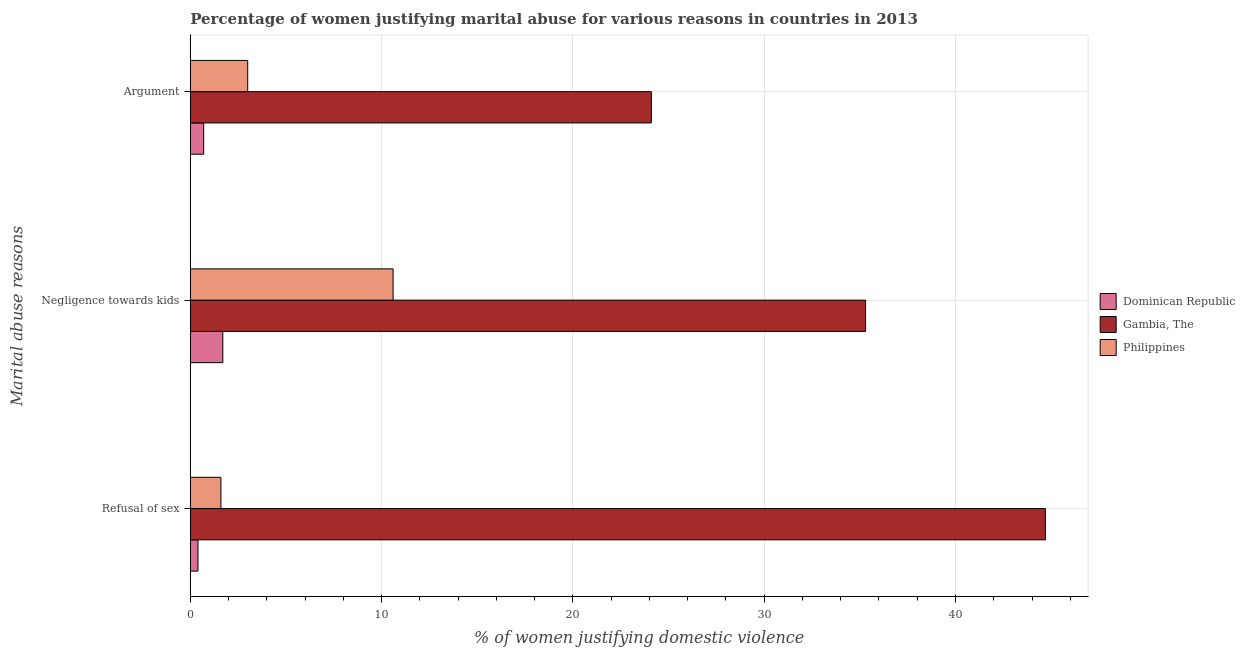How many different coloured bars are there?
Your answer should be compact. 3. How many groups of bars are there?
Provide a short and direct response. 3. Are the number of bars on each tick of the Y-axis equal?
Offer a very short reply. Yes. How many bars are there on the 2nd tick from the bottom?
Give a very brief answer. 3. What is the label of the 1st group of bars from the top?
Give a very brief answer. Argument. What is the percentage of women justifying domestic violence due to negligence towards kids in Dominican Republic?
Offer a terse response. 1.7. Across all countries, what is the maximum percentage of women justifying domestic violence due to refusal of sex?
Offer a terse response. 44.7. Across all countries, what is the minimum percentage of women justifying domestic violence due to negligence towards kids?
Your response must be concise. 1.7. In which country was the percentage of women justifying domestic violence due to refusal of sex maximum?
Make the answer very short. Gambia, The. In which country was the percentage of women justifying domestic violence due to arguments minimum?
Give a very brief answer. Dominican Republic. What is the total percentage of women justifying domestic violence due to arguments in the graph?
Your answer should be compact. 27.8. What is the difference between the percentage of women justifying domestic violence due to negligence towards kids in Philippines and that in Gambia, The?
Your answer should be very brief. -24.7. What is the average percentage of women justifying domestic violence due to arguments per country?
Make the answer very short. 9.27. What is the difference between the percentage of women justifying domestic violence due to arguments and percentage of women justifying domestic violence due to negligence towards kids in Dominican Republic?
Your answer should be compact. -1. In how many countries, is the percentage of women justifying domestic violence due to refusal of sex greater than 14 %?
Your answer should be compact. 1. What is the ratio of the percentage of women justifying domestic violence due to negligence towards kids in Gambia, The to that in Dominican Republic?
Ensure brevity in your answer.  20.76. Is the difference between the percentage of women justifying domestic violence due to arguments in Dominican Republic and Philippines greater than the difference between the percentage of women justifying domestic violence due to refusal of sex in Dominican Republic and Philippines?
Your response must be concise. No. What is the difference between the highest and the second highest percentage of women justifying domestic violence due to refusal of sex?
Make the answer very short. 43.1. What is the difference between the highest and the lowest percentage of women justifying domestic violence due to negligence towards kids?
Make the answer very short. 33.6. In how many countries, is the percentage of women justifying domestic violence due to refusal of sex greater than the average percentage of women justifying domestic violence due to refusal of sex taken over all countries?
Your answer should be compact. 1. Is the sum of the percentage of women justifying domestic violence due to refusal of sex in Philippines and Dominican Republic greater than the maximum percentage of women justifying domestic violence due to negligence towards kids across all countries?
Your response must be concise. No. What does the 3rd bar from the top in Negligence towards kids represents?
Offer a terse response. Dominican Republic. How many bars are there?
Provide a succinct answer. 9. Are all the bars in the graph horizontal?
Your response must be concise. Yes. What is the difference between two consecutive major ticks on the X-axis?
Offer a very short reply. 10. Are the values on the major ticks of X-axis written in scientific E-notation?
Offer a very short reply. No. Does the graph contain grids?
Your response must be concise. Yes. What is the title of the graph?
Ensure brevity in your answer.  Percentage of women justifying marital abuse for various reasons in countries in 2013. Does "Jamaica" appear as one of the legend labels in the graph?
Offer a terse response. No. What is the label or title of the X-axis?
Your response must be concise. % of women justifying domestic violence. What is the label or title of the Y-axis?
Offer a terse response. Marital abuse reasons. What is the % of women justifying domestic violence of Gambia, The in Refusal of sex?
Offer a very short reply. 44.7. What is the % of women justifying domestic violence of Dominican Republic in Negligence towards kids?
Offer a terse response. 1.7. What is the % of women justifying domestic violence in Gambia, The in Negligence towards kids?
Make the answer very short. 35.3. What is the % of women justifying domestic violence of Philippines in Negligence towards kids?
Ensure brevity in your answer.  10.6. What is the % of women justifying domestic violence of Dominican Republic in Argument?
Provide a succinct answer. 0.7. What is the % of women justifying domestic violence of Gambia, The in Argument?
Give a very brief answer. 24.1. What is the % of women justifying domestic violence in Philippines in Argument?
Your answer should be very brief. 3. Across all Marital abuse reasons, what is the maximum % of women justifying domestic violence of Dominican Republic?
Your answer should be very brief. 1.7. Across all Marital abuse reasons, what is the maximum % of women justifying domestic violence of Gambia, The?
Give a very brief answer. 44.7. Across all Marital abuse reasons, what is the minimum % of women justifying domestic violence in Gambia, The?
Offer a terse response. 24.1. What is the total % of women justifying domestic violence in Dominican Republic in the graph?
Give a very brief answer. 2.8. What is the total % of women justifying domestic violence in Gambia, The in the graph?
Your answer should be compact. 104.1. What is the difference between the % of women justifying domestic violence of Dominican Republic in Refusal of sex and that in Negligence towards kids?
Your answer should be very brief. -1.3. What is the difference between the % of women justifying domestic violence in Gambia, The in Refusal of sex and that in Negligence towards kids?
Your answer should be very brief. 9.4. What is the difference between the % of women justifying domestic violence in Philippines in Refusal of sex and that in Negligence towards kids?
Provide a short and direct response. -9. What is the difference between the % of women justifying domestic violence of Dominican Republic in Refusal of sex and that in Argument?
Offer a very short reply. -0.3. What is the difference between the % of women justifying domestic violence in Gambia, The in Refusal of sex and that in Argument?
Your response must be concise. 20.6. What is the difference between the % of women justifying domestic violence of Philippines in Refusal of sex and that in Argument?
Offer a terse response. -1.4. What is the difference between the % of women justifying domestic violence in Gambia, The in Negligence towards kids and that in Argument?
Give a very brief answer. 11.2. What is the difference between the % of women justifying domestic violence of Dominican Republic in Refusal of sex and the % of women justifying domestic violence of Gambia, The in Negligence towards kids?
Your answer should be very brief. -34.9. What is the difference between the % of women justifying domestic violence of Gambia, The in Refusal of sex and the % of women justifying domestic violence of Philippines in Negligence towards kids?
Ensure brevity in your answer.  34.1. What is the difference between the % of women justifying domestic violence in Dominican Republic in Refusal of sex and the % of women justifying domestic violence in Gambia, The in Argument?
Your answer should be compact. -23.7. What is the difference between the % of women justifying domestic violence of Gambia, The in Refusal of sex and the % of women justifying domestic violence of Philippines in Argument?
Your response must be concise. 41.7. What is the difference between the % of women justifying domestic violence in Dominican Republic in Negligence towards kids and the % of women justifying domestic violence in Gambia, The in Argument?
Make the answer very short. -22.4. What is the difference between the % of women justifying domestic violence in Gambia, The in Negligence towards kids and the % of women justifying domestic violence in Philippines in Argument?
Provide a short and direct response. 32.3. What is the average % of women justifying domestic violence in Dominican Republic per Marital abuse reasons?
Make the answer very short. 0.93. What is the average % of women justifying domestic violence of Gambia, The per Marital abuse reasons?
Offer a terse response. 34.7. What is the average % of women justifying domestic violence of Philippines per Marital abuse reasons?
Provide a succinct answer. 5.07. What is the difference between the % of women justifying domestic violence of Dominican Republic and % of women justifying domestic violence of Gambia, The in Refusal of sex?
Provide a short and direct response. -44.3. What is the difference between the % of women justifying domestic violence of Gambia, The and % of women justifying domestic violence of Philippines in Refusal of sex?
Offer a terse response. 43.1. What is the difference between the % of women justifying domestic violence in Dominican Republic and % of women justifying domestic violence in Gambia, The in Negligence towards kids?
Ensure brevity in your answer.  -33.6. What is the difference between the % of women justifying domestic violence of Dominican Republic and % of women justifying domestic violence of Philippines in Negligence towards kids?
Provide a succinct answer. -8.9. What is the difference between the % of women justifying domestic violence in Gambia, The and % of women justifying domestic violence in Philippines in Negligence towards kids?
Keep it short and to the point. 24.7. What is the difference between the % of women justifying domestic violence in Dominican Republic and % of women justifying domestic violence in Gambia, The in Argument?
Provide a succinct answer. -23.4. What is the difference between the % of women justifying domestic violence in Gambia, The and % of women justifying domestic violence in Philippines in Argument?
Your response must be concise. 21.1. What is the ratio of the % of women justifying domestic violence of Dominican Republic in Refusal of sex to that in Negligence towards kids?
Your response must be concise. 0.24. What is the ratio of the % of women justifying domestic violence in Gambia, The in Refusal of sex to that in Negligence towards kids?
Your response must be concise. 1.27. What is the ratio of the % of women justifying domestic violence of Philippines in Refusal of sex to that in Negligence towards kids?
Give a very brief answer. 0.15. What is the ratio of the % of women justifying domestic violence of Dominican Republic in Refusal of sex to that in Argument?
Make the answer very short. 0.57. What is the ratio of the % of women justifying domestic violence in Gambia, The in Refusal of sex to that in Argument?
Offer a terse response. 1.85. What is the ratio of the % of women justifying domestic violence of Philippines in Refusal of sex to that in Argument?
Offer a very short reply. 0.53. What is the ratio of the % of women justifying domestic violence of Dominican Republic in Negligence towards kids to that in Argument?
Make the answer very short. 2.43. What is the ratio of the % of women justifying domestic violence in Gambia, The in Negligence towards kids to that in Argument?
Your response must be concise. 1.46. What is the ratio of the % of women justifying domestic violence in Philippines in Negligence towards kids to that in Argument?
Offer a very short reply. 3.53. What is the difference between the highest and the second highest % of women justifying domestic violence of Philippines?
Keep it short and to the point. 7.6. What is the difference between the highest and the lowest % of women justifying domestic violence in Dominican Republic?
Keep it short and to the point. 1.3. What is the difference between the highest and the lowest % of women justifying domestic violence in Gambia, The?
Your answer should be compact. 20.6. 